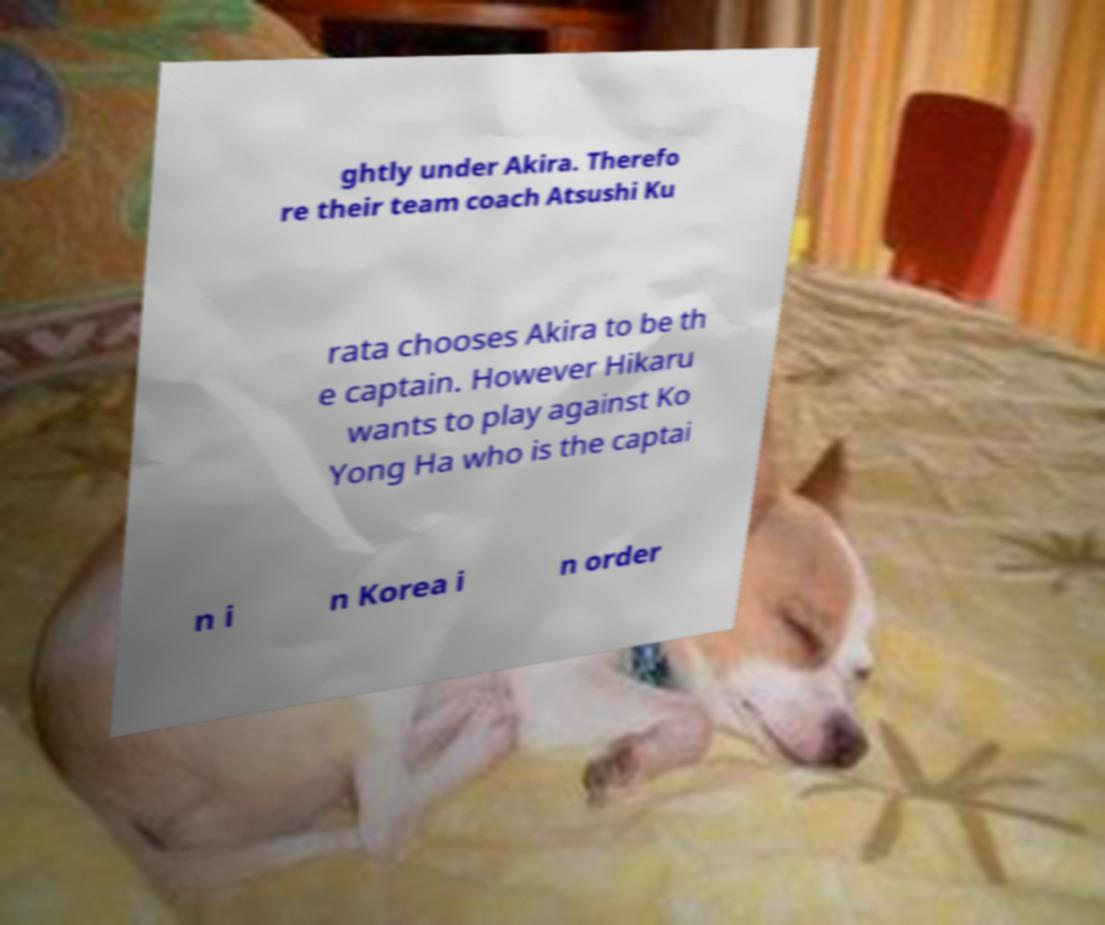Please read and relay the text visible in this image. What does it say? ghtly under Akira. Therefo re their team coach Atsushi Ku rata chooses Akira to be th e captain. However Hikaru wants to play against Ko Yong Ha who is the captai n i n Korea i n order 